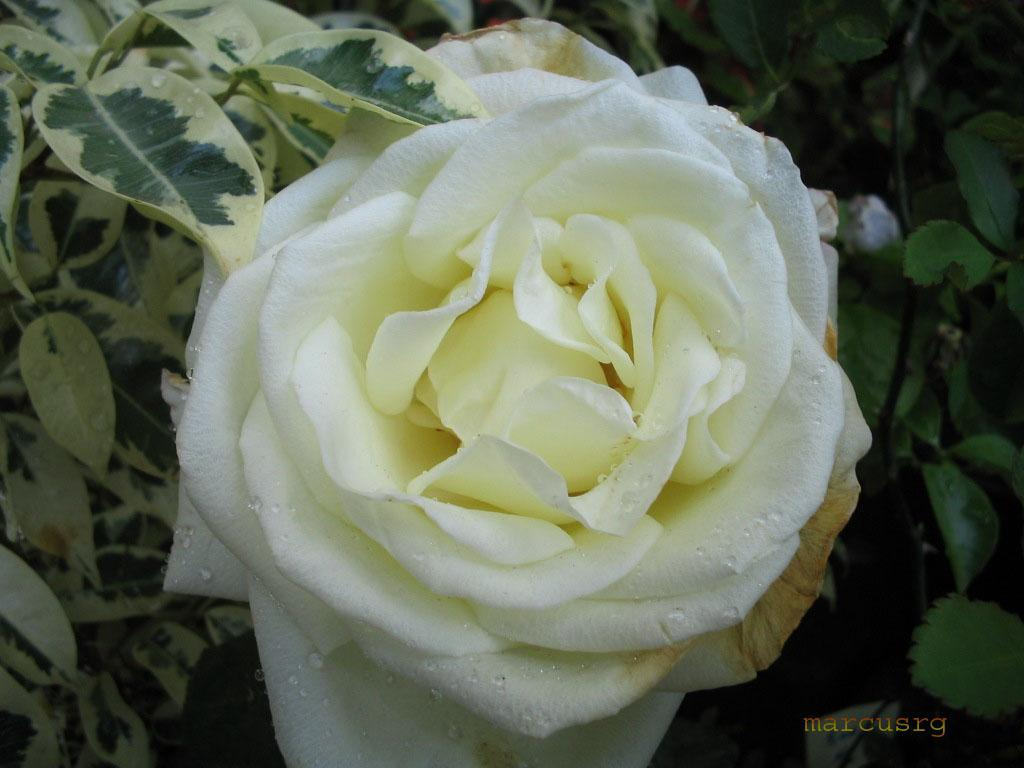What type of flower is visible in the image? There is a yellow and white flower in the image. Where is the flower located? The flower is attached to a tree. What color are the leaves of the tree in the image? The leaves of the tree are green and cream. Can you hear the writer laughing in the image? There is no writer or laughter present in the image; it features a yellow and white flower attached to a tree with green and cream leaves. 